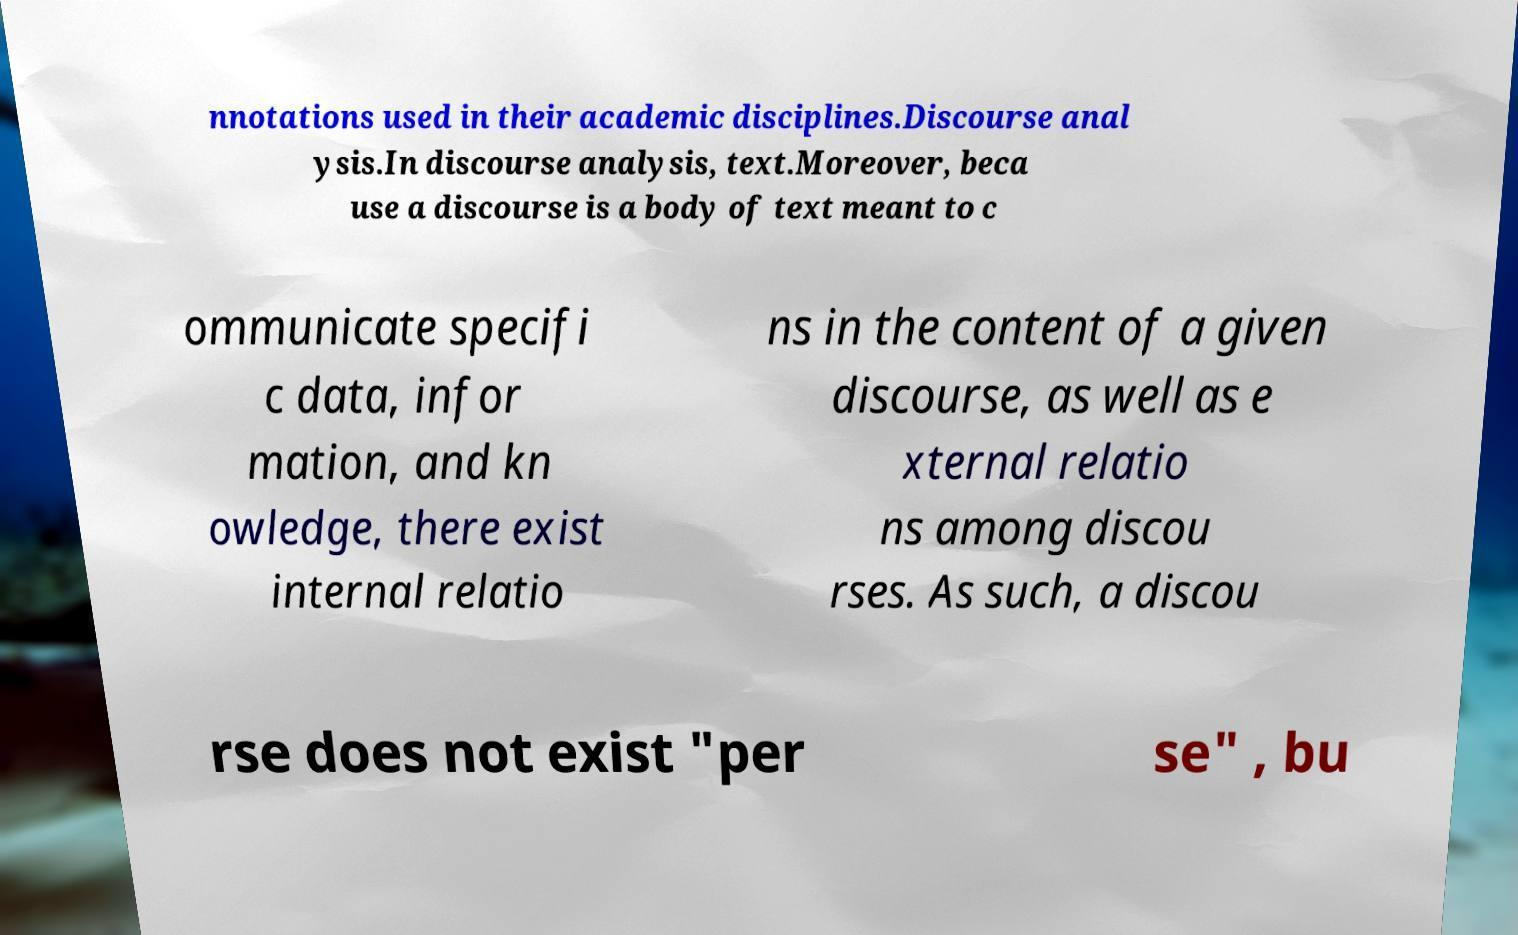For documentation purposes, I need the text within this image transcribed. Could you provide that? nnotations used in their academic disciplines.Discourse anal ysis.In discourse analysis, text.Moreover, beca use a discourse is a body of text meant to c ommunicate specifi c data, infor mation, and kn owledge, there exist internal relatio ns in the content of a given discourse, as well as e xternal relatio ns among discou rses. As such, a discou rse does not exist "per se" , bu 